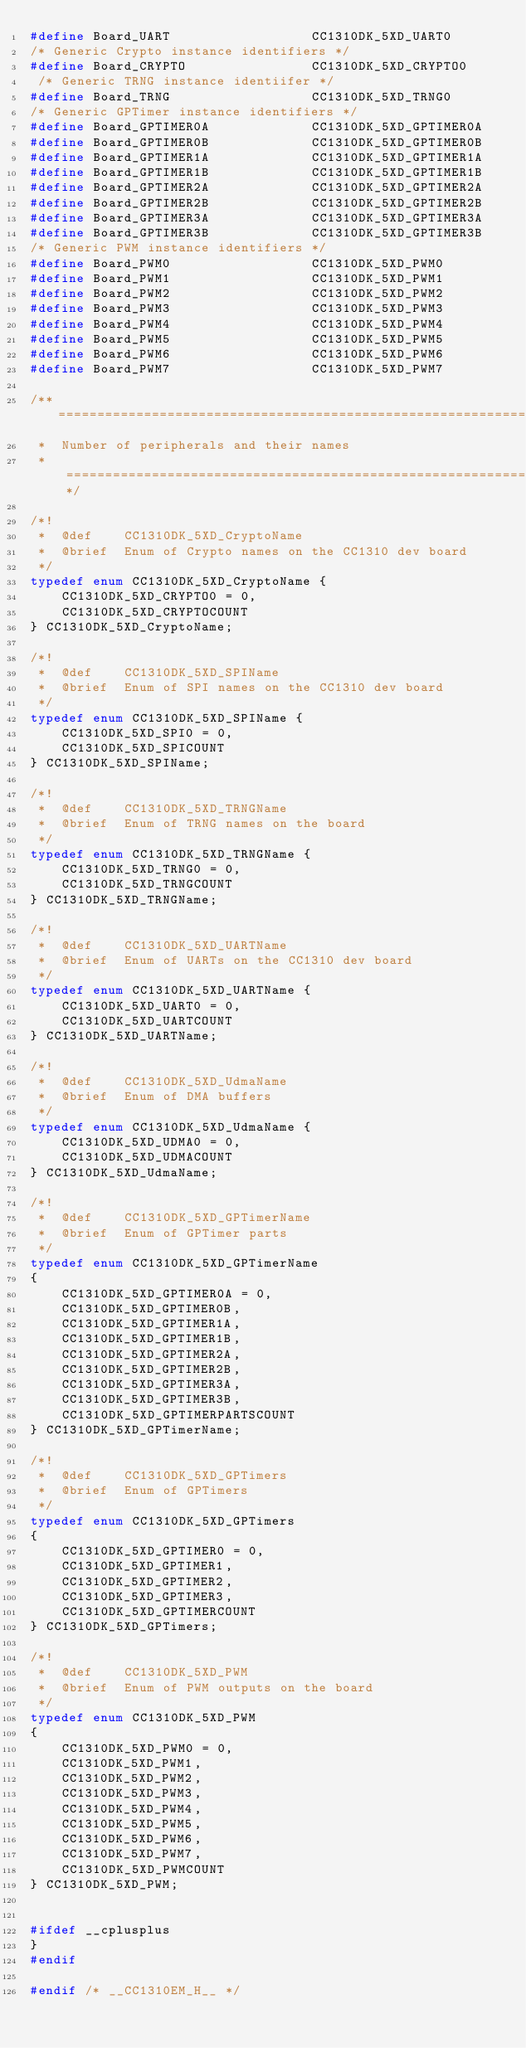Convert code to text. <code><loc_0><loc_0><loc_500><loc_500><_C_>#define Board_UART                  CC1310DK_5XD_UART0
/* Generic Crypto instance identifiers */
#define Board_CRYPTO                CC1310DK_5XD_CRYPTO0
 /* Generic TRNG instance identiifer */
#define Board_TRNG                  CC1310DK_5XD_TRNG0
/* Generic GPTimer instance identifiers */
#define Board_GPTIMER0A             CC1310DK_5XD_GPTIMER0A
#define Board_GPTIMER0B             CC1310DK_5XD_GPTIMER0B
#define Board_GPTIMER1A             CC1310DK_5XD_GPTIMER1A
#define Board_GPTIMER1B             CC1310DK_5XD_GPTIMER1B
#define Board_GPTIMER2A             CC1310DK_5XD_GPTIMER2A
#define Board_GPTIMER2B             CC1310DK_5XD_GPTIMER2B
#define Board_GPTIMER3A             CC1310DK_5XD_GPTIMER3A
#define Board_GPTIMER3B             CC1310DK_5XD_GPTIMER3B
/* Generic PWM instance identifiers */
#define Board_PWM0                  CC1310DK_5XD_PWM0
#define Board_PWM1                  CC1310DK_5XD_PWM1
#define Board_PWM2                  CC1310DK_5XD_PWM2
#define Board_PWM3                  CC1310DK_5XD_PWM3
#define Board_PWM4                  CC1310DK_5XD_PWM4
#define Board_PWM5                  CC1310DK_5XD_PWM5
#define Board_PWM6                  CC1310DK_5XD_PWM6
#define Board_PWM7                  CC1310DK_5XD_PWM7

/** ============================================================================
 *  Number of peripherals and their names
 *  ==========================================================================*/

/*!
 *  @def    CC1310DK_5XD_CryptoName
 *  @brief  Enum of Crypto names on the CC1310 dev board
 */
typedef enum CC1310DK_5XD_CryptoName {
    CC1310DK_5XD_CRYPTO0 = 0,
    CC1310DK_5XD_CRYPTOCOUNT
} CC1310DK_5XD_CryptoName;

/*!
 *  @def    CC1310DK_5XD_SPIName
 *  @brief  Enum of SPI names on the CC1310 dev board
 */
typedef enum CC1310DK_5XD_SPIName {
    CC1310DK_5XD_SPI0 = 0,
    CC1310DK_5XD_SPICOUNT
} CC1310DK_5XD_SPIName;

/*!
 *  @def    CC1310DK_5XD_TRNGName
 *  @brief  Enum of TRNG names on the board
 */
typedef enum CC1310DK_5XD_TRNGName {
    CC1310DK_5XD_TRNG0 = 0,   
    CC1310DK_5XD_TRNGCOUNT
} CC1310DK_5XD_TRNGName;

/*!
 *  @def    CC1310DK_5XD_UARTName
 *  @brief  Enum of UARTs on the CC1310 dev board
 */
typedef enum CC1310DK_5XD_UARTName {
    CC1310DK_5XD_UART0 = 0,
    CC1310DK_5XD_UARTCOUNT
} CC1310DK_5XD_UARTName;

/*!
 *  @def    CC1310DK_5XD_UdmaName
 *  @brief  Enum of DMA buffers
 */
typedef enum CC1310DK_5XD_UdmaName {
    CC1310DK_5XD_UDMA0 = 0,
    CC1310DK_5XD_UDMACOUNT
} CC1310DK_5XD_UdmaName;

/*!
 *  @def    CC1310DK_5XD_GPTimerName
 *  @brief  Enum of GPTimer parts
 */
typedef enum CC1310DK_5XD_GPTimerName
{
    CC1310DK_5XD_GPTIMER0A = 0,
    CC1310DK_5XD_GPTIMER0B,
    CC1310DK_5XD_GPTIMER1A,
    CC1310DK_5XD_GPTIMER1B,
    CC1310DK_5XD_GPTIMER2A,
    CC1310DK_5XD_GPTIMER2B,
    CC1310DK_5XD_GPTIMER3A,
    CC1310DK_5XD_GPTIMER3B,
    CC1310DK_5XD_GPTIMERPARTSCOUNT
} CC1310DK_5XD_GPTimerName;

/*!
 *  @def    CC1310DK_5XD_GPTimers
 *  @brief  Enum of GPTimers
 */
typedef enum CC1310DK_5XD_GPTimers
{
    CC1310DK_5XD_GPTIMER0 = 0,
    CC1310DK_5XD_GPTIMER1,
    CC1310DK_5XD_GPTIMER2,
    CC1310DK_5XD_GPTIMER3,
    CC1310DK_5XD_GPTIMERCOUNT
} CC1310DK_5XD_GPTimers;

/*!
 *  @def    CC1310DK_5XD_PWM
 *  @brief  Enum of PWM outputs on the board
 */
typedef enum CC1310DK_5XD_PWM
{
    CC1310DK_5XD_PWM0 = 0,
    CC1310DK_5XD_PWM1,
    CC1310DK_5XD_PWM2,
    CC1310DK_5XD_PWM3,
    CC1310DK_5XD_PWM4,
    CC1310DK_5XD_PWM5,
    CC1310DK_5XD_PWM6,
    CC1310DK_5XD_PWM7,
    CC1310DK_5XD_PWMCOUNT
} CC1310DK_5XD_PWM;


#ifdef __cplusplus
}
#endif

#endif /* __CC1310EM_H__ */
</code> 